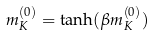<formula> <loc_0><loc_0><loc_500><loc_500>m _ { K } ^ { ( 0 ) } = \tanh ( \beta m _ { K } ^ { ( 0 ) } )</formula> 